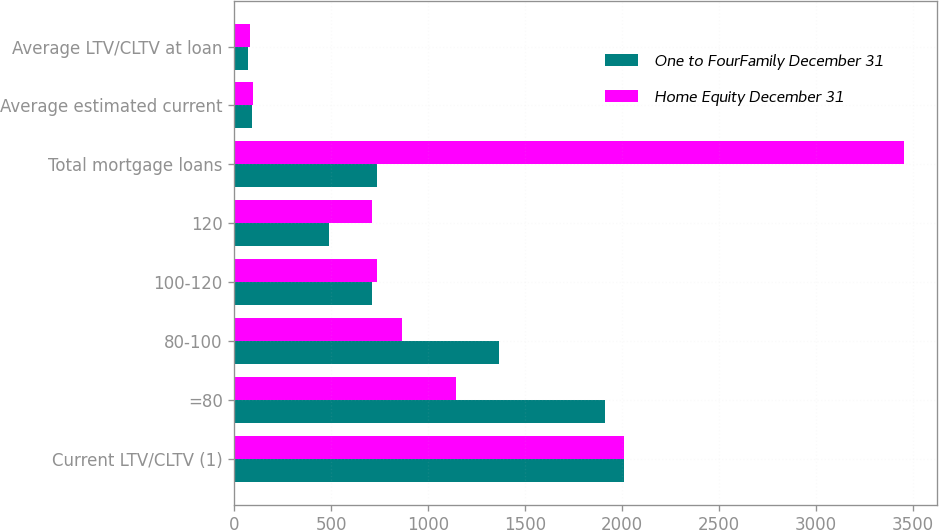Convert chart to OTSL. <chart><loc_0><loc_0><loc_500><loc_500><stacked_bar_chart><ecel><fcel>Current LTV/CLTV (1)<fcel>=80<fcel>80-100<fcel>100-120<fcel>120<fcel>Total mortgage loans<fcel>Average estimated current<fcel>Average LTV/CLTV at loan<nl><fcel>One to FourFamily December 31<fcel>2013<fcel>1911.6<fcel>1364.9<fcel>711.6<fcel>486.7<fcel>735.6<fcel>89.9<fcel>71.5<nl><fcel>Home Equity December 31<fcel>2013<fcel>1142<fcel>866.5<fcel>735.6<fcel>709.9<fcel>3454<fcel>97.9<fcel>79.7<nl></chart> 